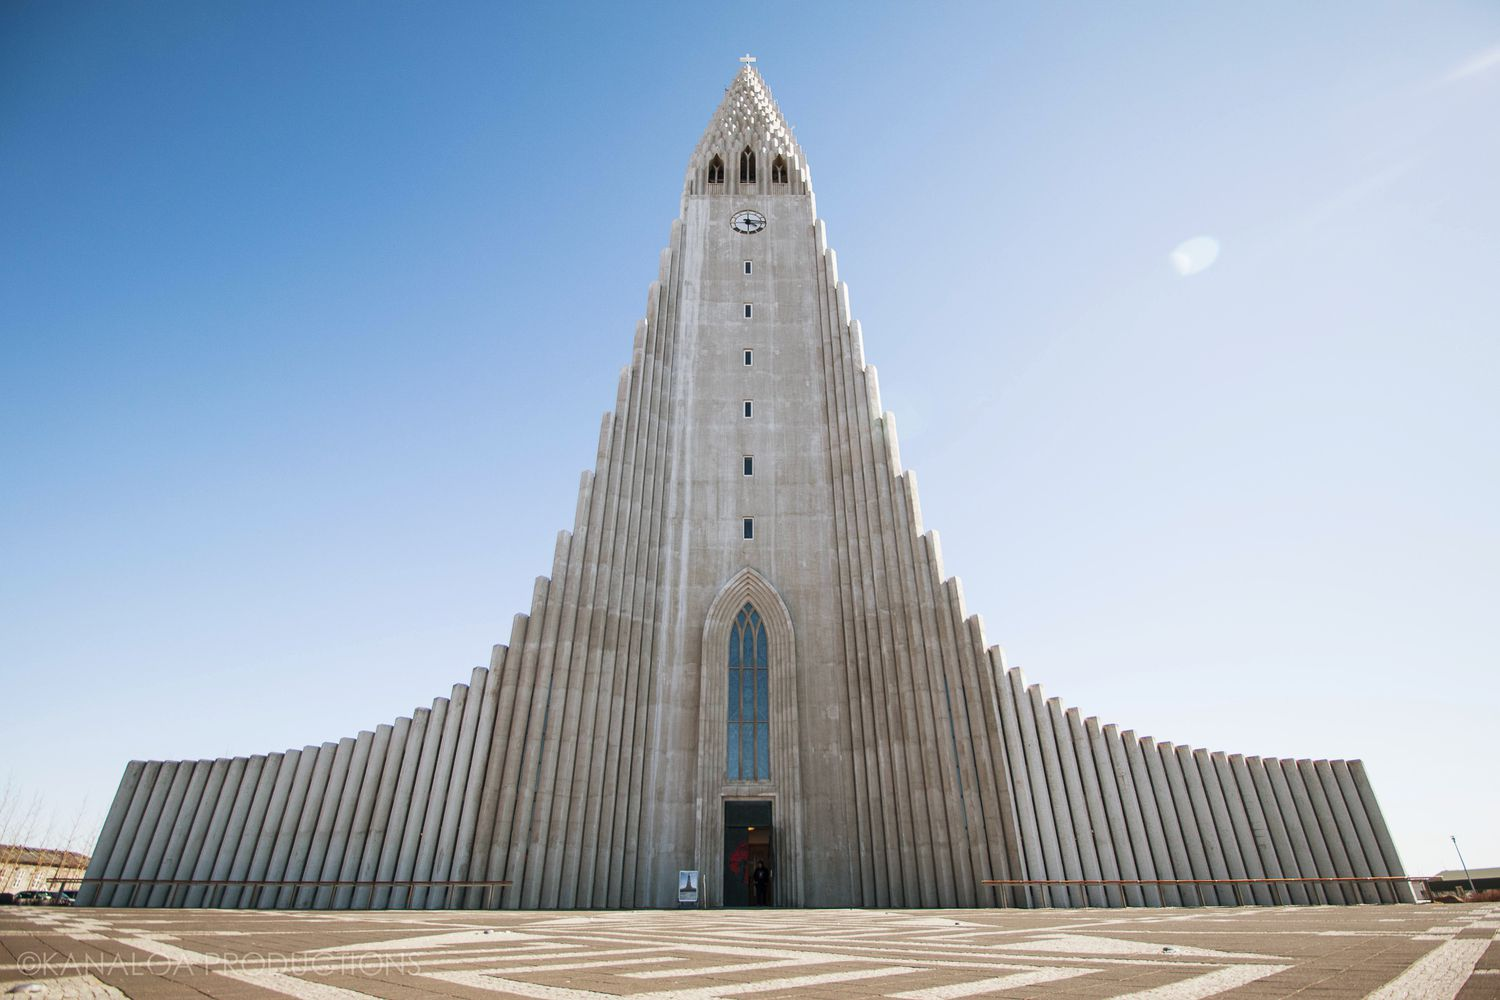Can you describe another interesting detail about this church? One fascinating detail about Hallgrímskirkja is its impressive pipe organ, which is a remarkable feat of engineering. The organ was designed and constructed by the German organ builder Johannes Klais of Bonn. Standing at 15 meters (49 feet) in height and weighing a staggering 25 tons, it features 5,275 pipes. The organ's majestic sound complements the visual splendor of the church, making it not only a place for worship but also a significant venue for musical performances. 